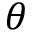Convert formula to latex. <formula><loc_0><loc_0><loc_500><loc_500>\theta</formula> 